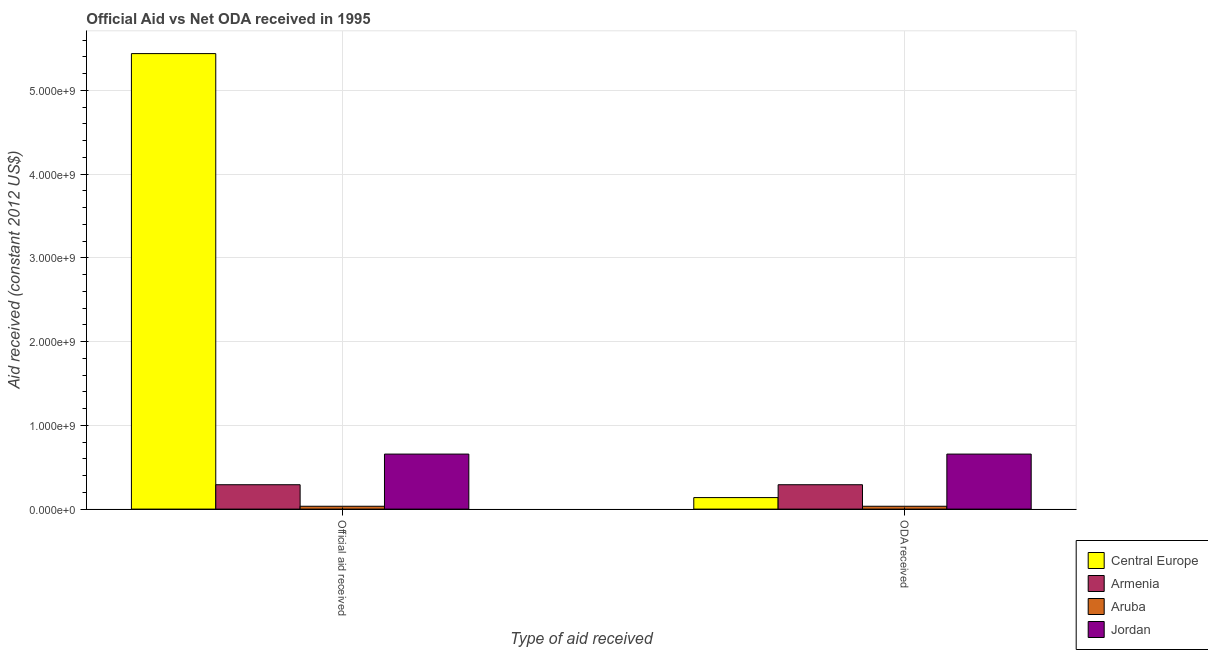Are the number of bars per tick equal to the number of legend labels?
Ensure brevity in your answer.  Yes. How many bars are there on the 1st tick from the left?
Give a very brief answer. 4. How many bars are there on the 1st tick from the right?
Ensure brevity in your answer.  4. What is the label of the 2nd group of bars from the left?
Keep it short and to the point. ODA received. What is the official aid received in Jordan?
Provide a succinct answer. 6.57e+08. Across all countries, what is the maximum oda received?
Offer a terse response. 6.57e+08. Across all countries, what is the minimum oda received?
Ensure brevity in your answer.  3.40e+07. In which country was the oda received maximum?
Offer a very short reply. Jordan. In which country was the oda received minimum?
Offer a very short reply. Aruba. What is the total oda received in the graph?
Your answer should be very brief. 1.12e+09. What is the difference between the oda received in Armenia and that in Aruba?
Ensure brevity in your answer.  2.57e+08. What is the difference between the official aid received in Jordan and the oda received in Aruba?
Offer a very short reply. 6.23e+08. What is the average official aid received per country?
Provide a succinct answer. 1.61e+09. What is the difference between the oda received and official aid received in Central Europe?
Offer a terse response. -5.30e+09. In how many countries, is the official aid received greater than 200000000 US$?
Your answer should be compact. 3. What is the ratio of the official aid received in Central Europe to that in Aruba?
Offer a terse response. 159.88. What does the 3rd bar from the left in Official aid received represents?
Provide a succinct answer. Aruba. What does the 1st bar from the right in Official aid received represents?
Make the answer very short. Jordan. How many bars are there?
Keep it short and to the point. 8. How many countries are there in the graph?
Offer a terse response. 4. What is the difference between two consecutive major ticks on the Y-axis?
Provide a succinct answer. 1.00e+09. Are the values on the major ticks of Y-axis written in scientific E-notation?
Your answer should be very brief. Yes. Does the graph contain grids?
Provide a succinct answer. Yes. Where does the legend appear in the graph?
Keep it short and to the point. Bottom right. How are the legend labels stacked?
Your answer should be compact. Vertical. What is the title of the graph?
Give a very brief answer. Official Aid vs Net ODA received in 1995 . What is the label or title of the X-axis?
Give a very brief answer. Type of aid received. What is the label or title of the Y-axis?
Ensure brevity in your answer.  Aid received (constant 2012 US$). What is the Aid received (constant 2012 US$) in Central Europe in Official aid received?
Your answer should be compact. 5.44e+09. What is the Aid received (constant 2012 US$) of Armenia in Official aid received?
Ensure brevity in your answer.  2.91e+08. What is the Aid received (constant 2012 US$) of Aruba in Official aid received?
Your answer should be very brief. 3.40e+07. What is the Aid received (constant 2012 US$) of Jordan in Official aid received?
Ensure brevity in your answer.  6.57e+08. What is the Aid received (constant 2012 US$) in Central Europe in ODA received?
Your response must be concise. 1.38e+08. What is the Aid received (constant 2012 US$) of Armenia in ODA received?
Keep it short and to the point. 2.91e+08. What is the Aid received (constant 2012 US$) in Aruba in ODA received?
Your response must be concise. 3.40e+07. What is the Aid received (constant 2012 US$) in Jordan in ODA received?
Ensure brevity in your answer.  6.57e+08. Across all Type of aid received, what is the maximum Aid received (constant 2012 US$) in Central Europe?
Give a very brief answer. 5.44e+09. Across all Type of aid received, what is the maximum Aid received (constant 2012 US$) in Armenia?
Your response must be concise. 2.91e+08. Across all Type of aid received, what is the maximum Aid received (constant 2012 US$) in Aruba?
Your answer should be compact. 3.40e+07. Across all Type of aid received, what is the maximum Aid received (constant 2012 US$) in Jordan?
Ensure brevity in your answer.  6.57e+08. Across all Type of aid received, what is the minimum Aid received (constant 2012 US$) of Central Europe?
Your answer should be very brief. 1.38e+08. Across all Type of aid received, what is the minimum Aid received (constant 2012 US$) in Armenia?
Offer a very short reply. 2.91e+08. Across all Type of aid received, what is the minimum Aid received (constant 2012 US$) of Aruba?
Your answer should be compact. 3.40e+07. Across all Type of aid received, what is the minimum Aid received (constant 2012 US$) in Jordan?
Ensure brevity in your answer.  6.57e+08. What is the total Aid received (constant 2012 US$) of Central Europe in the graph?
Offer a very short reply. 5.58e+09. What is the total Aid received (constant 2012 US$) of Armenia in the graph?
Offer a terse response. 5.82e+08. What is the total Aid received (constant 2012 US$) in Aruba in the graph?
Your response must be concise. 6.80e+07. What is the total Aid received (constant 2012 US$) of Jordan in the graph?
Your answer should be compact. 1.31e+09. What is the difference between the Aid received (constant 2012 US$) of Central Europe in Official aid received and that in ODA received?
Offer a very short reply. 5.30e+09. What is the difference between the Aid received (constant 2012 US$) of Armenia in Official aid received and that in ODA received?
Your answer should be compact. 0. What is the difference between the Aid received (constant 2012 US$) of Jordan in Official aid received and that in ODA received?
Your answer should be compact. 0. What is the difference between the Aid received (constant 2012 US$) in Central Europe in Official aid received and the Aid received (constant 2012 US$) in Armenia in ODA received?
Provide a succinct answer. 5.15e+09. What is the difference between the Aid received (constant 2012 US$) in Central Europe in Official aid received and the Aid received (constant 2012 US$) in Aruba in ODA received?
Offer a terse response. 5.41e+09. What is the difference between the Aid received (constant 2012 US$) of Central Europe in Official aid received and the Aid received (constant 2012 US$) of Jordan in ODA received?
Offer a terse response. 4.78e+09. What is the difference between the Aid received (constant 2012 US$) in Armenia in Official aid received and the Aid received (constant 2012 US$) in Aruba in ODA received?
Make the answer very short. 2.57e+08. What is the difference between the Aid received (constant 2012 US$) of Armenia in Official aid received and the Aid received (constant 2012 US$) of Jordan in ODA received?
Provide a short and direct response. -3.66e+08. What is the difference between the Aid received (constant 2012 US$) of Aruba in Official aid received and the Aid received (constant 2012 US$) of Jordan in ODA received?
Make the answer very short. -6.23e+08. What is the average Aid received (constant 2012 US$) of Central Europe per Type of aid received?
Your answer should be very brief. 2.79e+09. What is the average Aid received (constant 2012 US$) of Armenia per Type of aid received?
Provide a succinct answer. 2.91e+08. What is the average Aid received (constant 2012 US$) in Aruba per Type of aid received?
Your answer should be compact. 3.40e+07. What is the average Aid received (constant 2012 US$) in Jordan per Type of aid received?
Provide a succinct answer. 6.57e+08. What is the difference between the Aid received (constant 2012 US$) of Central Europe and Aid received (constant 2012 US$) of Armenia in Official aid received?
Give a very brief answer. 5.15e+09. What is the difference between the Aid received (constant 2012 US$) in Central Europe and Aid received (constant 2012 US$) in Aruba in Official aid received?
Provide a short and direct response. 5.41e+09. What is the difference between the Aid received (constant 2012 US$) of Central Europe and Aid received (constant 2012 US$) of Jordan in Official aid received?
Your response must be concise. 4.78e+09. What is the difference between the Aid received (constant 2012 US$) in Armenia and Aid received (constant 2012 US$) in Aruba in Official aid received?
Ensure brevity in your answer.  2.57e+08. What is the difference between the Aid received (constant 2012 US$) in Armenia and Aid received (constant 2012 US$) in Jordan in Official aid received?
Keep it short and to the point. -3.66e+08. What is the difference between the Aid received (constant 2012 US$) of Aruba and Aid received (constant 2012 US$) of Jordan in Official aid received?
Keep it short and to the point. -6.23e+08. What is the difference between the Aid received (constant 2012 US$) in Central Europe and Aid received (constant 2012 US$) in Armenia in ODA received?
Your response must be concise. -1.53e+08. What is the difference between the Aid received (constant 2012 US$) of Central Europe and Aid received (constant 2012 US$) of Aruba in ODA received?
Provide a short and direct response. 1.04e+08. What is the difference between the Aid received (constant 2012 US$) of Central Europe and Aid received (constant 2012 US$) of Jordan in ODA received?
Provide a succinct answer. -5.19e+08. What is the difference between the Aid received (constant 2012 US$) in Armenia and Aid received (constant 2012 US$) in Aruba in ODA received?
Give a very brief answer. 2.57e+08. What is the difference between the Aid received (constant 2012 US$) in Armenia and Aid received (constant 2012 US$) in Jordan in ODA received?
Your answer should be compact. -3.66e+08. What is the difference between the Aid received (constant 2012 US$) in Aruba and Aid received (constant 2012 US$) in Jordan in ODA received?
Provide a succinct answer. -6.23e+08. What is the ratio of the Aid received (constant 2012 US$) of Central Europe in Official aid received to that in ODA received?
Offer a terse response. 39.54. What is the difference between the highest and the second highest Aid received (constant 2012 US$) of Central Europe?
Your response must be concise. 5.30e+09. What is the difference between the highest and the second highest Aid received (constant 2012 US$) of Armenia?
Ensure brevity in your answer.  0. What is the difference between the highest and the second highest Aid received (constant 2012 US$) in Aruba?
Provide a succinct answer. 0. What is the difference between the highest and the second highest Aid received (constant 2012 US$) of Jordan?
Provide a short and direct response. 0. What is the difference between the highest and the lowest Aid received (constant 2012 US$) of Central Europe?
Your response must be concise. 5.30e+09. 